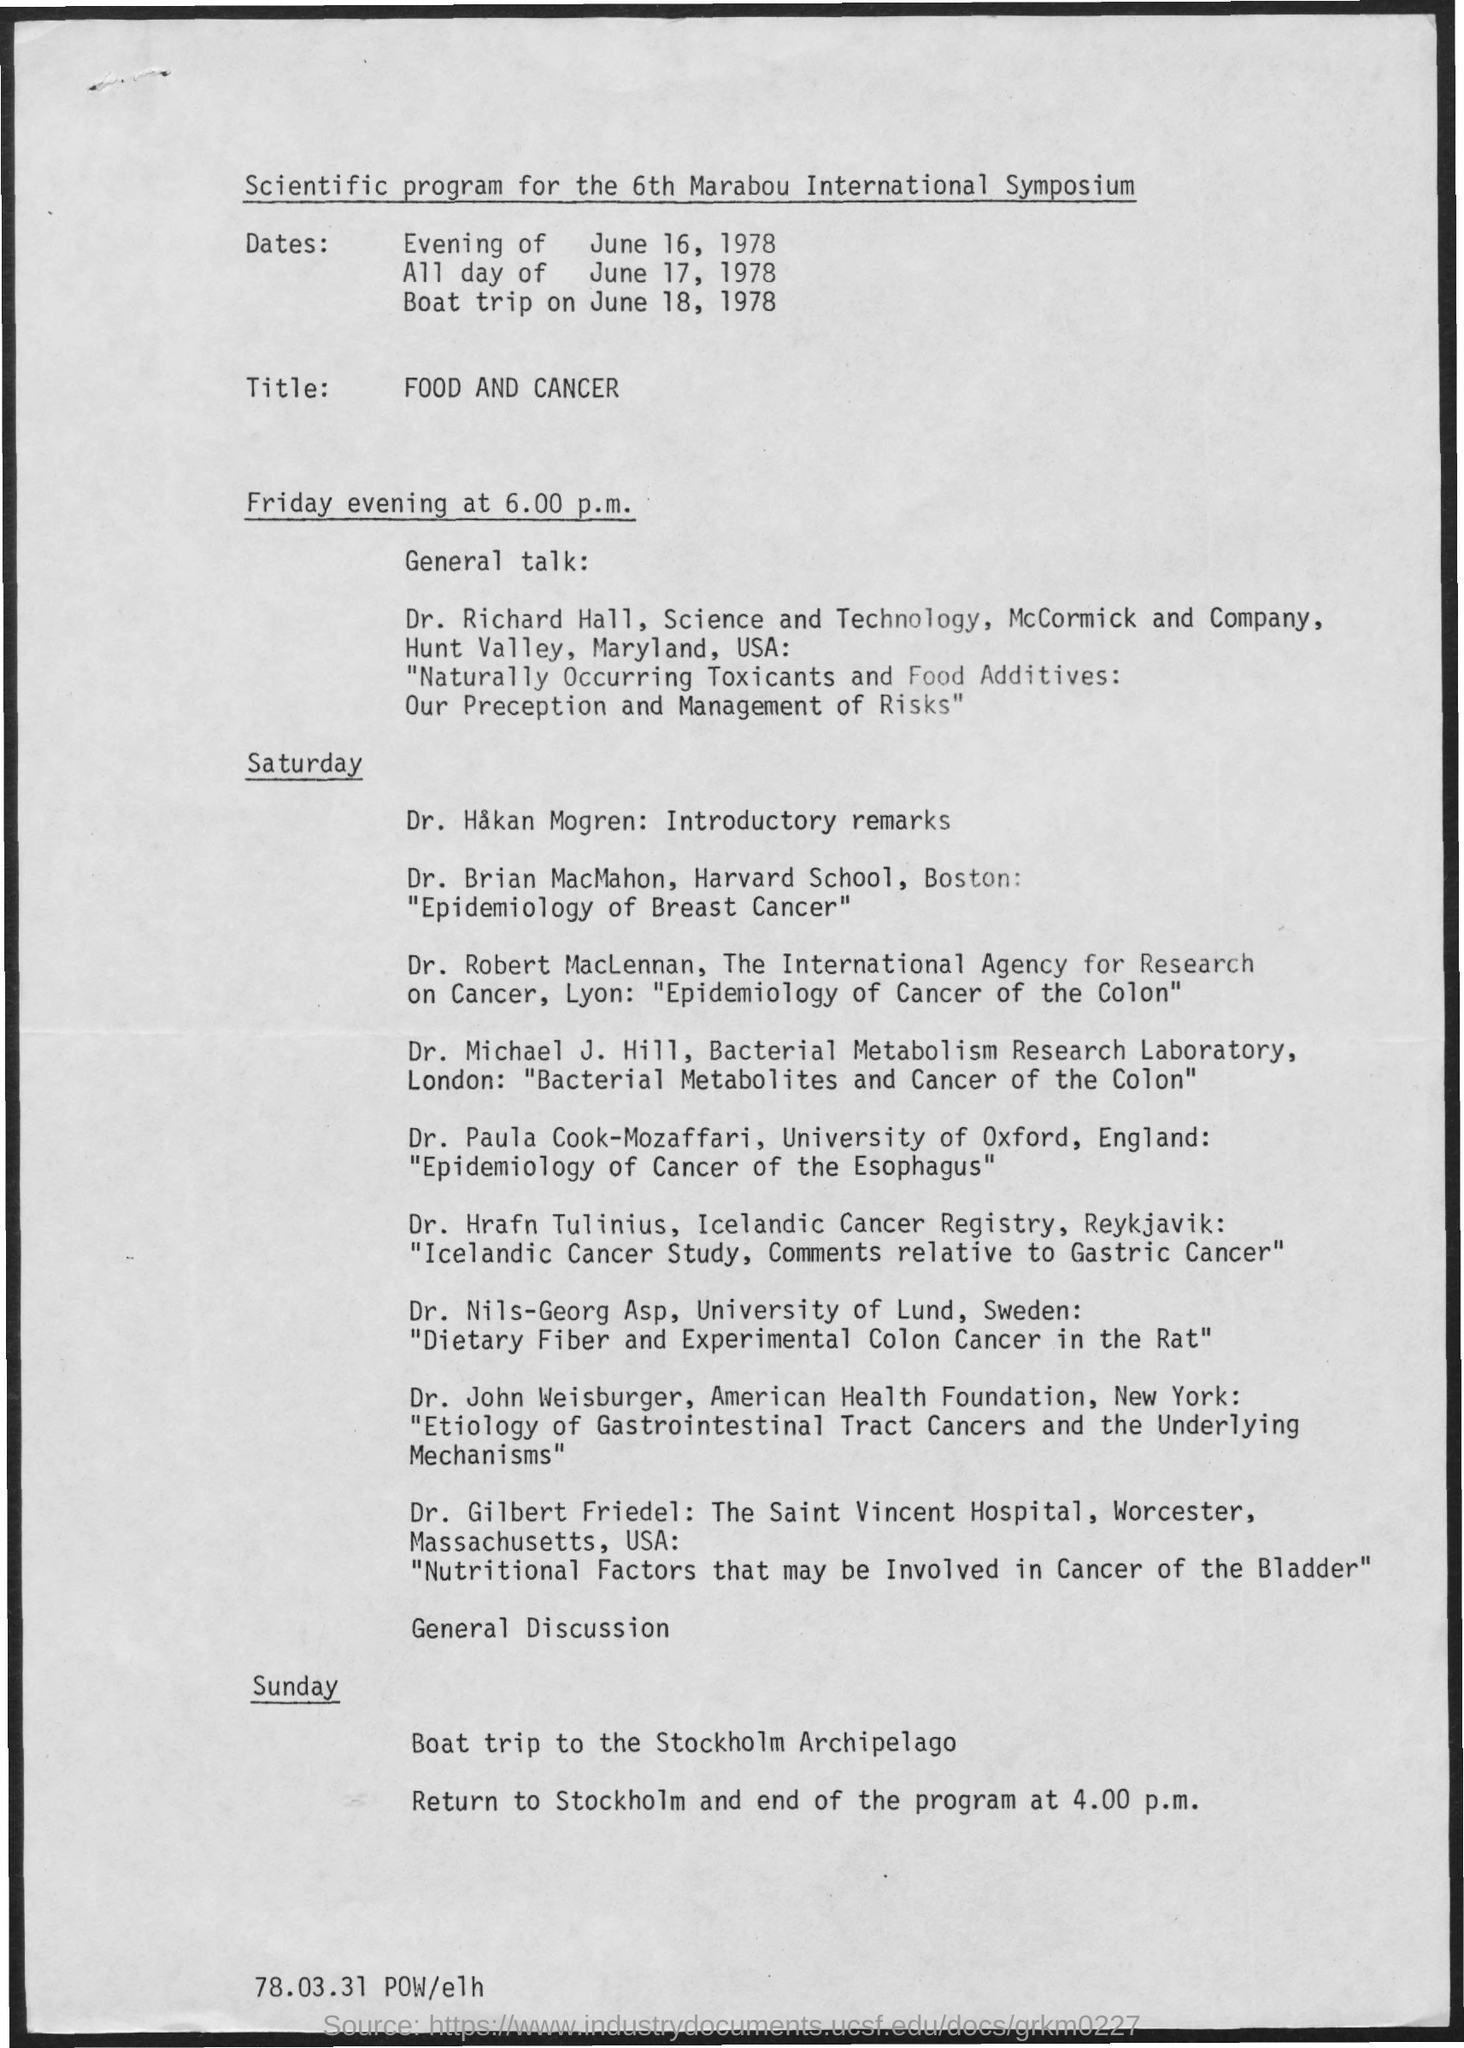Where is the boat trip to?
Provide a succinct answer. Stockholm Archipelago. When is the Boat trip?
Keep it short and to the point. Sunday. When is the General Talk?
Your answer should be compact. Friday evening at 6.00 p.m. When is the General Discussion?
Offer a terse response. Saturday. What is the Scientific Program for?
Provide a short and direct response. 6th Marabou International Symposium. 